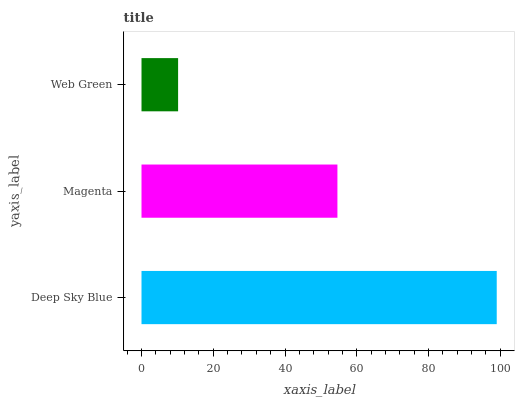Is Web Green the minimum?
Answer yes or no. Yes. Is Deep Sky Blue the maximum?
Answer yes or no. Yes. Is Magenta the minimum?
Answer yes or no. No. Is Magenta the maximum?
Answer yes or no. No. Is Deep Sky Blue greater than Magenta?
Answer yes or no. Yes. Is Magenta less than Deep Sky Blue?
Answer yes or no. Yes. Is Magenta greater than Deep Sky Blue?
Answer yes or no. No. Is Deep Sky Blue less than Magenta?
Answer yes or no. No. Is Magenta the high median?
Answer yes or no. Yes. Is Magenta the low median?
Answer yes or no. Yes. Is Deep Sky Blue the high median?
Answer yes or no. No. Is Web Green the low median?
Answer yes or no. No. 